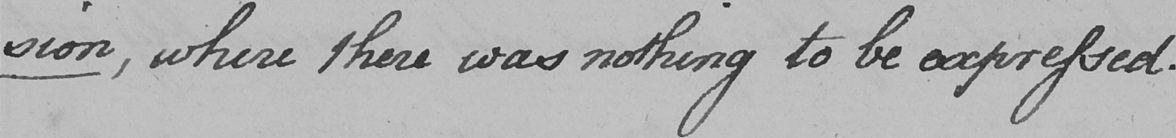Can you read and transcribe this handwriting? -sion ,  where there was nothing to be expressed . 